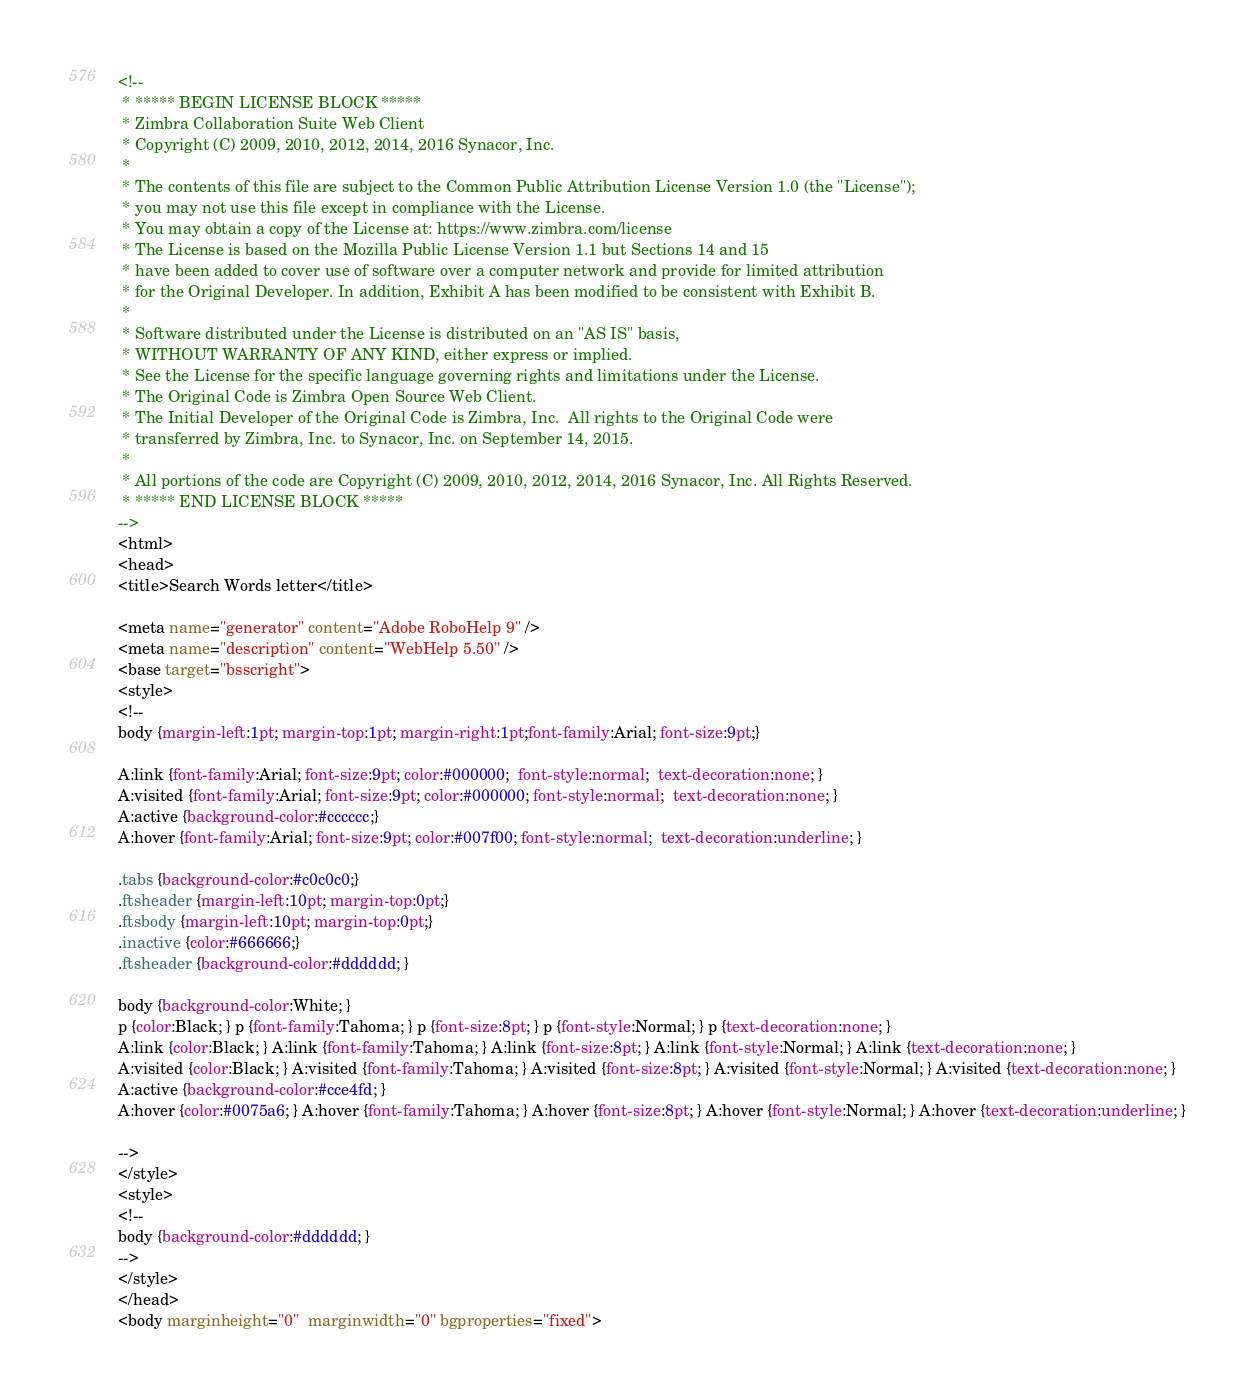<code> <loc_0><loc_0><loc_500><loc_500><_HTML_><!--
 * ***** BEGIN LICENSE BLOCK *****
 * Zimbra Collaboration Suite Web Client
 * Copyright (C) 2009, 2010, 2012, 2014, 2016 Synacor, Inc.
 *
 * The contents of this file are subject to the Common Public Attribution License Version 1.0 (the "License");
 * you may not use this file except in compliance with the License.
 * You may obtain a copy of the License at: https://www.zimbra.com/license
 * The License is based on the Mozilla Public License Version 1.1 but Sections 14 and 15
 * have been added to cover use of software over a computer network and provide for limited attribution
 * for the Original Developer. In addition, Exhibit A has been modified to be consistent with Exhibit B.
 *
 * Software distributed under the License is distributed on an "AS IS" basis,
 * WITHOUT WARRANTY OF ANY KIND, either express or implied.
 * See the License for the specific language governing rights and limitations under the License.
 * The Original Code is Zimbra Open Source Web Client.
 * The Initial Developer of the Original Code is Zimbra, Inc.  All rights to the Original Code were
 * transferred by Zimbra, Inc. to Synacor, Inc. on September 14, 2015.
 *
 * All portions of the code are Copyright (C) 2009, 2010, 2012, 2014, 2016 Synacor, Inc. All Rights Reserved.
 * ***** END LICENSE BLOCK *****
-->
<html>
<head>
<title>Search Words letter</title>

<meta name="generator" content="Adobe RoboHelp 9" />
<meta name="description" content="WebHelp 5.50" />
<base target="bsscright">
<style>
<!--
body {margin-left:1pt; margin-top:1pt; margin-right:1pt;font-family:Arial; font-size:9pt;}

A:link {font-family:Arial; font-size:9pt; color:#000000;  font-style:normal;  text-decoration:none; }
A:visited {font-family:Arial; font-size:9pt; color:#000000; font-style:normal;  text-decoration:none; }
A:active {background-color:#cccccc;}
A:hover {font-family:Arial; font-size:9pt; color:#007f00; font-style:normal;  text-decoration:underline; }

.tabs {background-color:#c0c0c0;}
.ftsheader {margin-left:10pt; margin-top:0pt;}
.ftsbody {margin-left:10pt; margin-top:0pt;}
.inactive {color:#666666;}
.ftsheader {background-color:#dddddd; } 

body {background-color:White; } 
p {color:Black; } p {font-family:Tahoma; } p {font-size:8pt; } p {font-style:Normal; } p {text-decoration:none; } 
A:link {color:Black; } A:link {font-family:Tahoma; } A:link {font-size:8pt; } A:link {font-style:Normal; } A:link {text-decoration:none; } 
A:visited {color:Black; } A:visited {font-family:Tahoma; } A:visited {font-size:8pt; } A:visited {font-style:Normal; } A:visited {text-decoration:none; } 
A:active {background-color:#cce4fd; } 
A:hover {color:#0075a6; } A:hover {font-family:Tahoma; } A:hover {font-size:8pt; } A:hover {font-style:Normal; } A:hover {text-decoration:underline; } 

-->
</style>
<style>
<!--
body {background-color:#dddddd; } 
-->
</style>
</head>
<body marginheight="0"  marginwidth="0" bgproperties="fixed">
</code> 